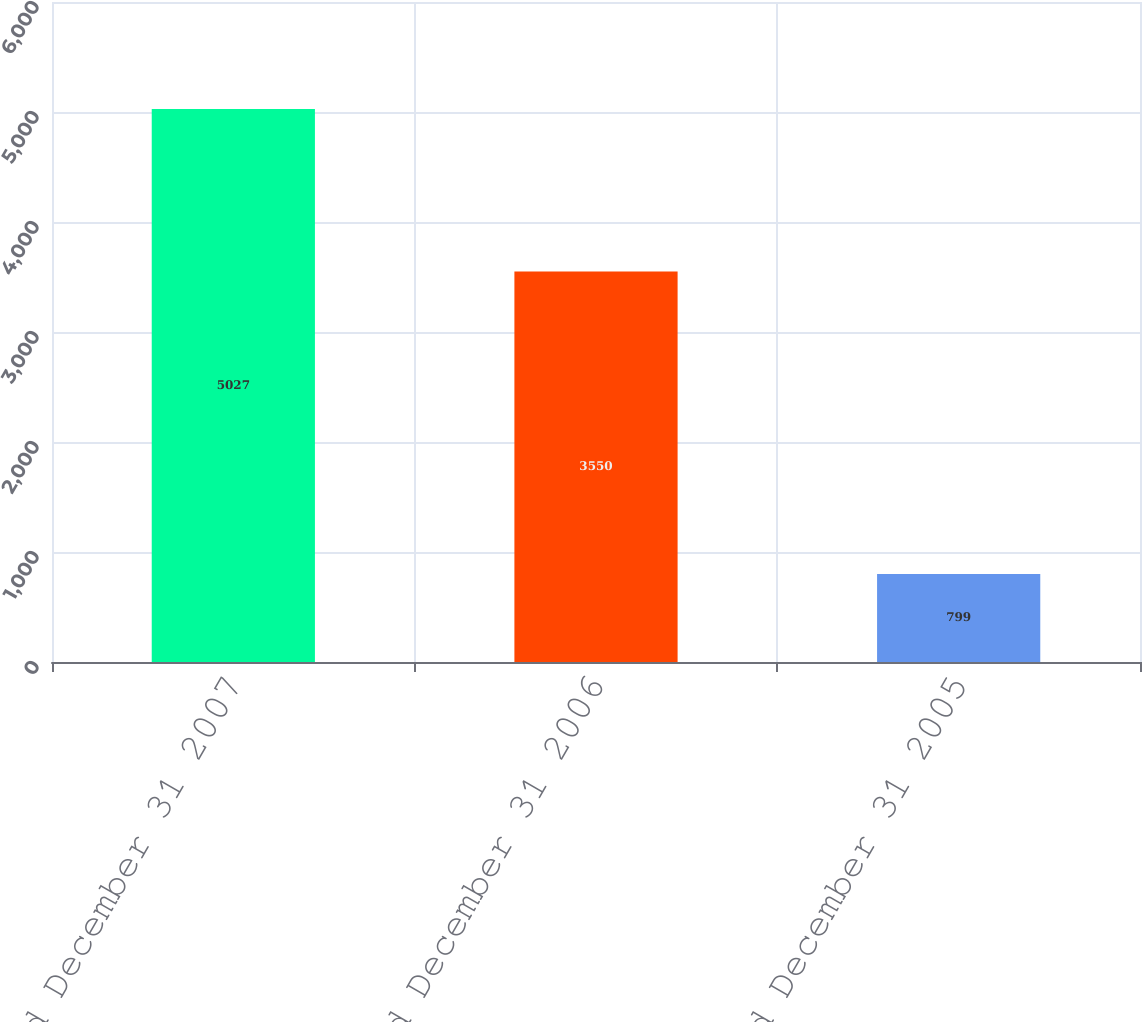<chart> <loc_0><loc_0><loc_500><loc_500><bar_chart><fcel>Year Ended December 31 2007<fcel>Year Ended December 31 2006<fcel>Year Ended December 31 2005<nl><fcel>5027<fcel>3550<fcel>799<nl></chart> 